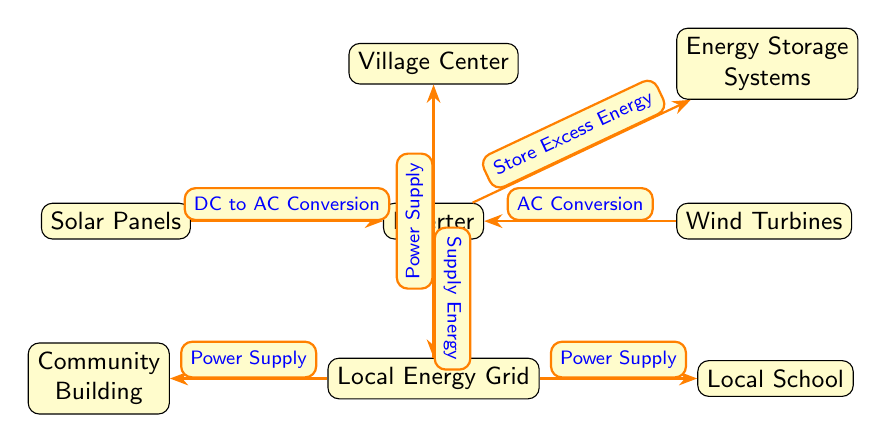what are the two renewable energy sources depicted in the diagram? The diagram shows two renewable energy sources: Solar Panels and Wind Turbines, which are positioned below the Village Center.
Answer: Solar Panels and Wind Turbines what is the function of the inverter in the diagram? The inverter serves two main purposes: it converts the direct current (DC) from the Solar Panels to alternating current (AC), and it also converts the AC from the Wind Turbines to AC compatible for the energy grid.
Answer: DC to AC Conversion and AC Conversion how many pathways are there leading from the inverter? The inverter has two outgoing pathways; one leads to the Energy Storage Systems and the other leads to the Local Energy Grid.
Answer: 2 which node receives Power Supply from the Local Energy Grid? The Local Energy Grid supplies power to three nodes: the Village Center, the Community Building, and the Local School. Therefore, all three are receiving Power Supply, but the question specifically concerns one of them. The Village Center is the first noted in the diagram.
Answer: Village Center what is the role of Energy Storage Systems in the diagram? The Energy Storage Systems are designed to store excess energy generated by the inverter, ensuring that available energy can be utilized when needed.
Answer: Store Excess Energy how does the energy flow from solar panels to the village center? The flow begins at the Solar Panels, where energy is collected and converted by the inverter, then supplied to the Local Energy Grid. Finally, the Local Energy Grid provides Power Supply to the Village Center.
Answer: Through inverter to grid what is the relationship between the Community Building and the Local Energy Grid? The Community Building receives Power Supply from the Local Energy Grid, showcasing a direct dependency on the energy produced and managed by the grid.
Answer: Power Supply how many total nodes are represented in this diagram? The diagram comprises 6 nodes: Village Center, Solar Panels, Wind Turbines, Inverter, Energy Storage Systems, and Local Energy Grid.
Answer: 6 what is the output of energy conversion from the solar panels? The output energy from the Solar Panels is converted from DC to AC by the inverter, making it suitable for local use.
Answer: AC 